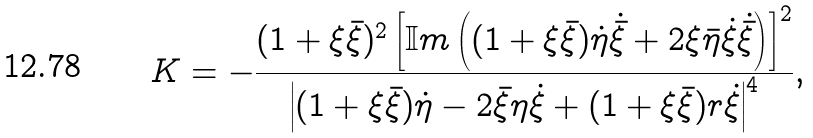Convert formula to latex. <formula><loc_0><loc_0><loc_500><loc_500>K = - \frac { ( 1 + \xi \bar { \xi } ) ^ { 2 } \left [ { \mathbb { I } } { m } \left ( ( 1 + \xi \bar { \xi } ) \dot { \eta } \dot { \bar { \xi } } + 2 \xi \bar { \eta } \dot { \xi } \dot { \bar { \xi } } \right ) \right ] ^ { 2 } } { \left | ( 1 + \xi \bar { \xi } ) \dot { \eta } - 2 \bar { \xi } \eta \dot { \xi } + ( 1 + \xi \bar { \xi } ) r \dot { \xi } \right | ^ { 4 } } ,</formula> 